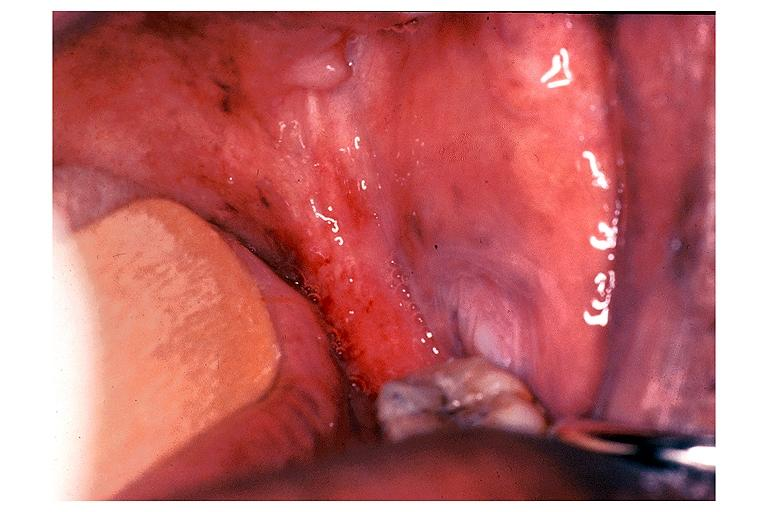where is this?
Answer the question using a single word or phrase. Oral 